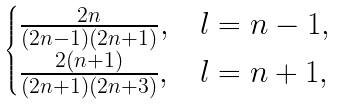Convert formula to latex. <formula><loc_0><loc_0><loc_500><loc_500>\begin{cases} \frac { 2 n } { ( 2 n - 1 ) ( 2 n + 1 ) } , & l = n - 1 , \\ \frac { 2 ( n + 1 ) } { ( 2 n + 1 ) ( 2 n + 3 ) } , & l = n + 1 , \end{cases}</formula> 